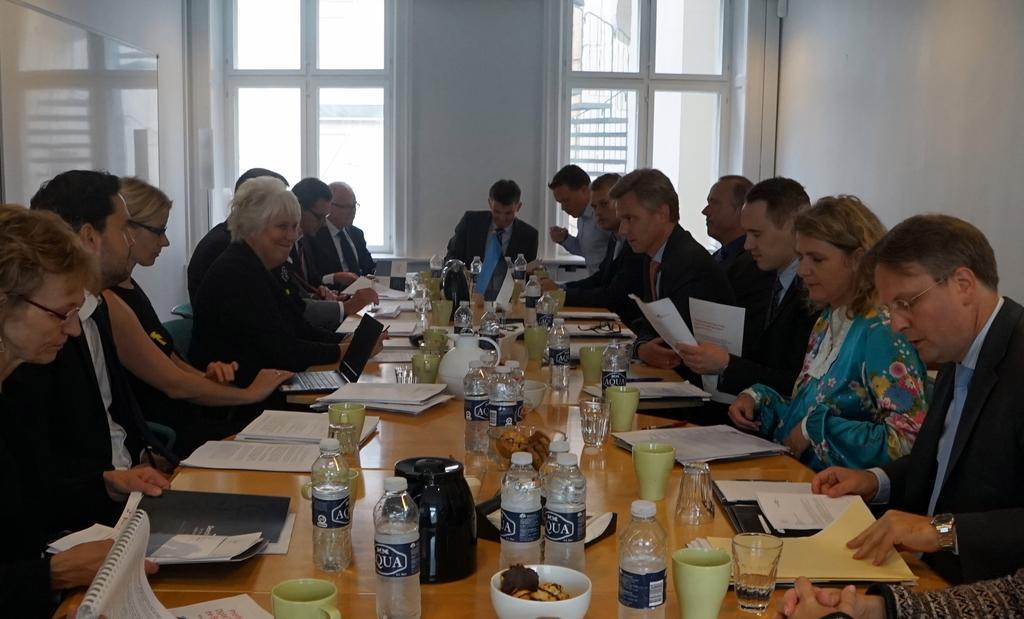Describe this image in one or two sentences. There are people sitting on chairs and this man holding papers. We can see bottles,papers,cups,glasses,bowls,kettles,laptop and objects on the table. In the background we can see wall and glass windows. 